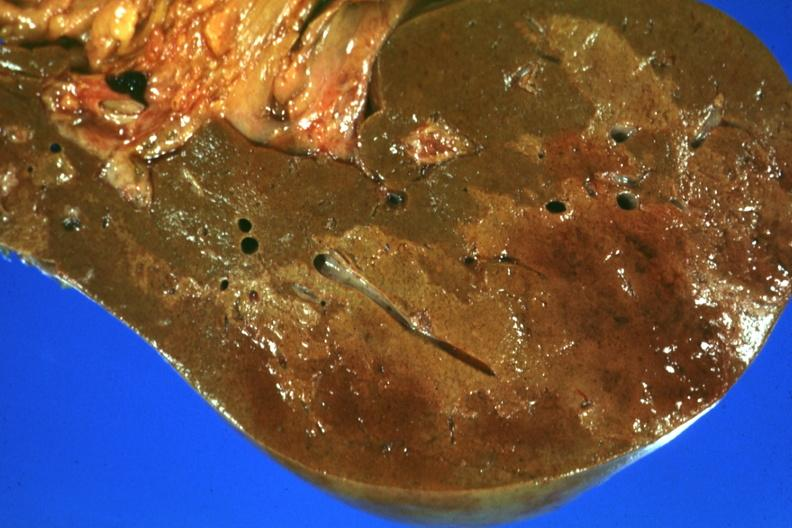s thymus present?
Answer the question using a single word or phrase. No 